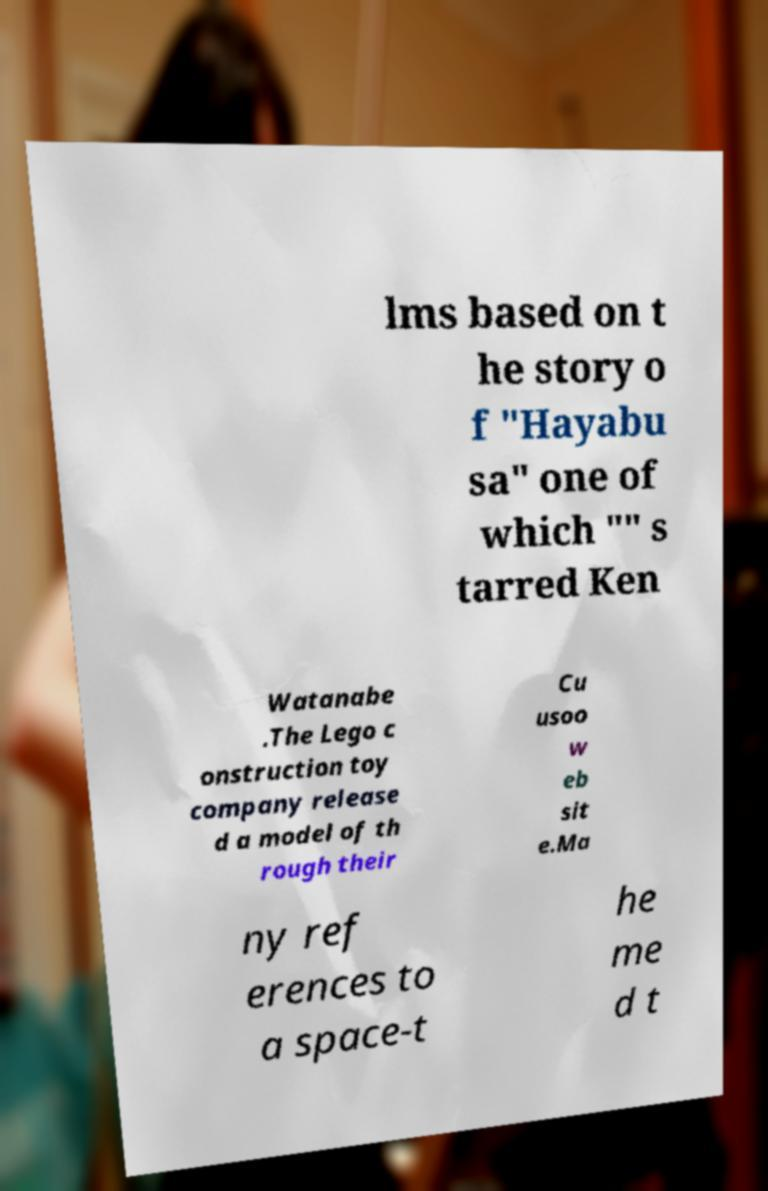Could you extract and type out the text from this image? lms based on t he story o f "Hayabu sa" one of which "" s tarred Ken Watanabe .The Lego c onstruction toy company release d a model of th rough their Cu usoo w eb sit e.Ma ny ref erences to a space-t he me d t 